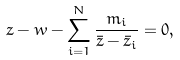Convert formula to latex. <formula><loc_0><loc_0><loc_500><loc_500>z - w - \sum _ { i = 1 } ^ { N } \frac { m _ { i } } { \bar { z } - \bar { z } _ { i } } = 0 ,</formula> 